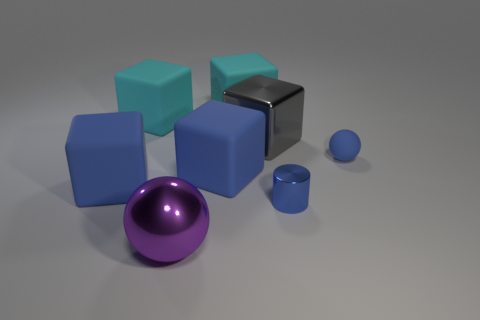Are there any big cyan things of the same shape as the big gray object?
Offer a very short reply. Yes. There is a gray shiny object that is the same size as the purple object; what is its shape?
Your answer should be very brief. Cube. The small thing that is behind the small blue thing in front of the rubber object on the right side of the gray metallic cube is what shape?
Offer a terse response. Sphere. Is the shape of the gray object the same as the large blue matte object that is to the right of the large purple shiny thing?
Your answer should be very brief. Yes. How many tiny objects are either cyan things or gray shiny cubes?
Offer a terse response. 0. Are there any purple cylinders that have the same size as the metallic block?
Ensure brevity in your answer.  No. There is a matte object to the right of the small blue thing that is left of the matte thing to the right of the large gray shiny object; what is its color?
Give a very brief answer. Blue. Do the large ball and the ball that is right of the large metallic cube have the same material?
Your response must be concise. No. There is a purple metallic thing that is the same shape as the tiny matte thing; what size is it?
Provide a short and direct response. Large. Is the number of tiny blue matte things that are left of the cylinder the same as the number of small blue balls to the right of the purple ball?
Give a very brief answer. No. 